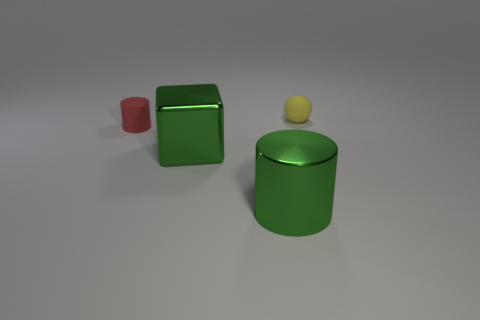Add 3 tiny yellow matte balls. How many objects exist? 7 Subtract all red cylinders. How many cylinders are left? 1 Subtract all blocks. How many objects are left? 3 Subtract all green cylinders. Subtract all purple spheres. How many cylinders are left? 1 Subtract all brown blocks. How many blue spheres are left? 0 Subtract all yellow spheres. Subtract all cylinders. How many objects are left? 1 Add 3 small yellow matte balls. How many small yellow matte balls are left? 4 Add 3 large cylinders. How many large cylinders exist? 4 Subtract 0 brown cylinders. How many objects are left? 4 